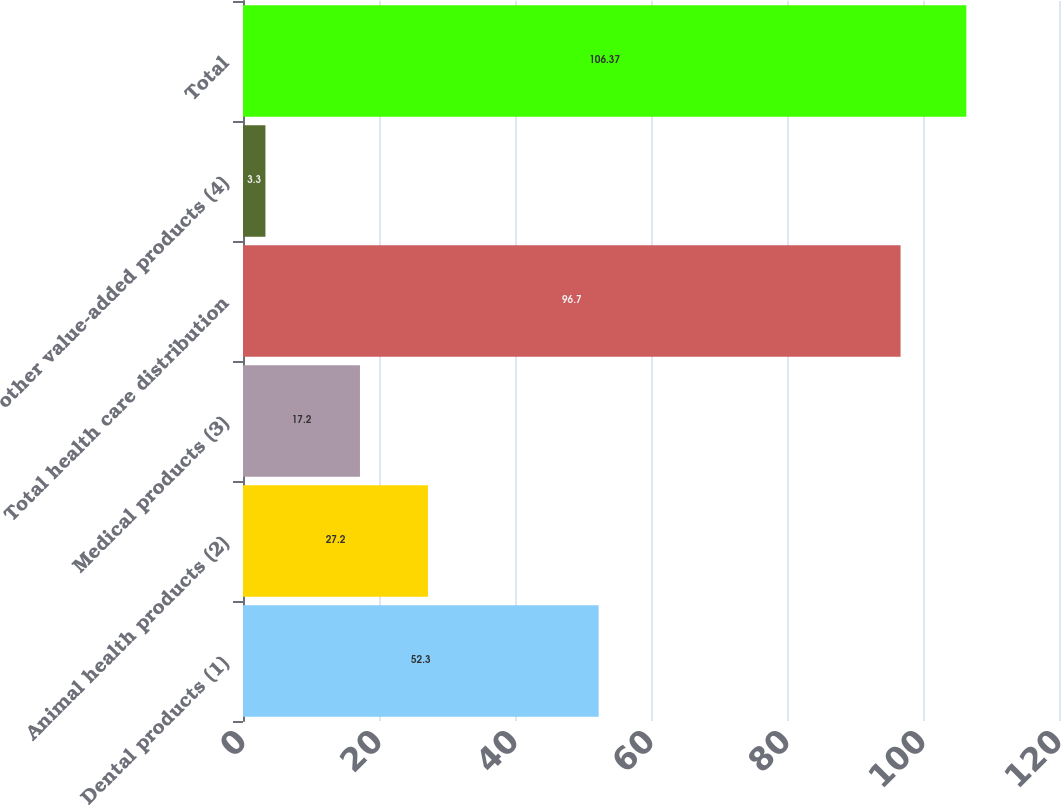Convert chart to OTSL. <chart><loc_0><loc_0><loc_500><loc_500><bar_chart><fcel>Dental products (1)<fcel>Animal health products (2)<fcel>Medical products (3)<fcel>Total health care distribution<fcel>other value-added products (4)<fcel>Total<nl><fcel>52.3<fcel>27.2<fcel>17.2<fcel>96.7<fcel>3.3<fcel>106.37<nl></chart> 